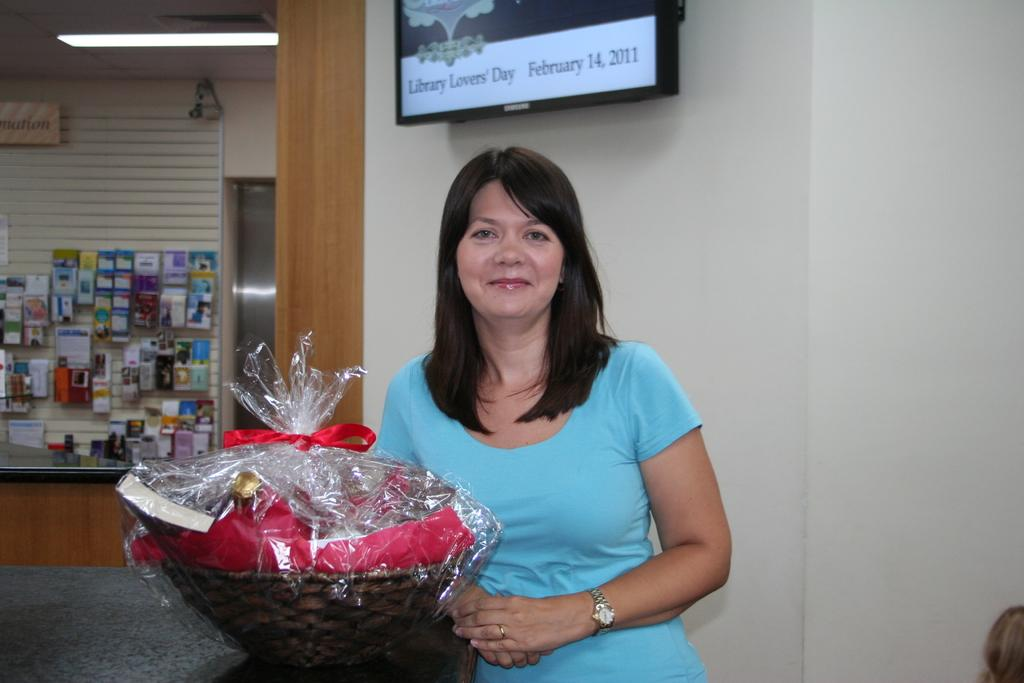Who is present in the image? There is a woman in the image. What is the woman wearing? The woman is wearing a sky blue dress. What can be seen in the background of the image? The background of the image includes covers. What objects are present in the image? There is a wall, a basket, a table, a screen, a light, and a banner in the image. What type of mass is being held in the image? There is no mention of a mass or any religious context in the image. 